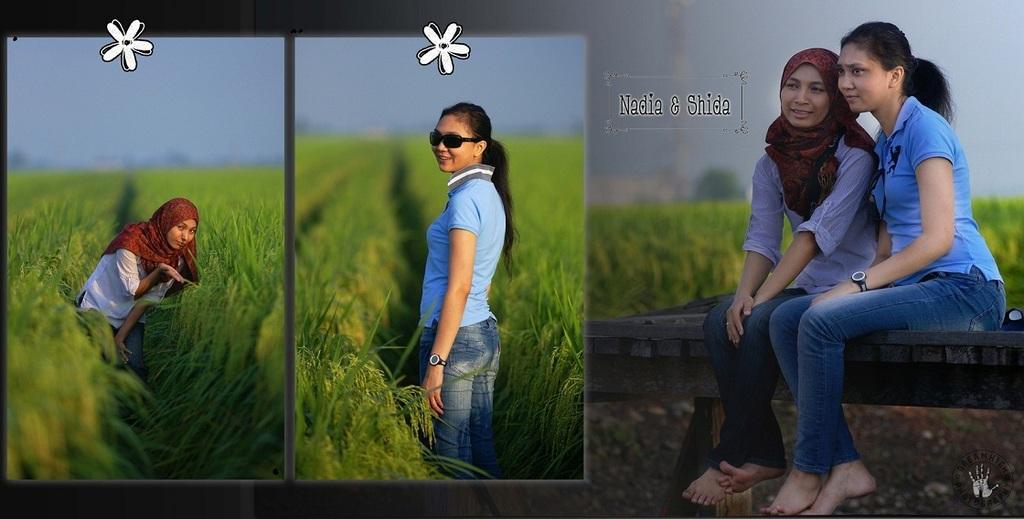In one or two sentences, can you explain what this image depicts? This is an edited image. In the left a lady is standing in the field. In the middle the lady wearing glasses is standing in the grain field. In the right two ladies are sitting on a table. In the background there are plants. 